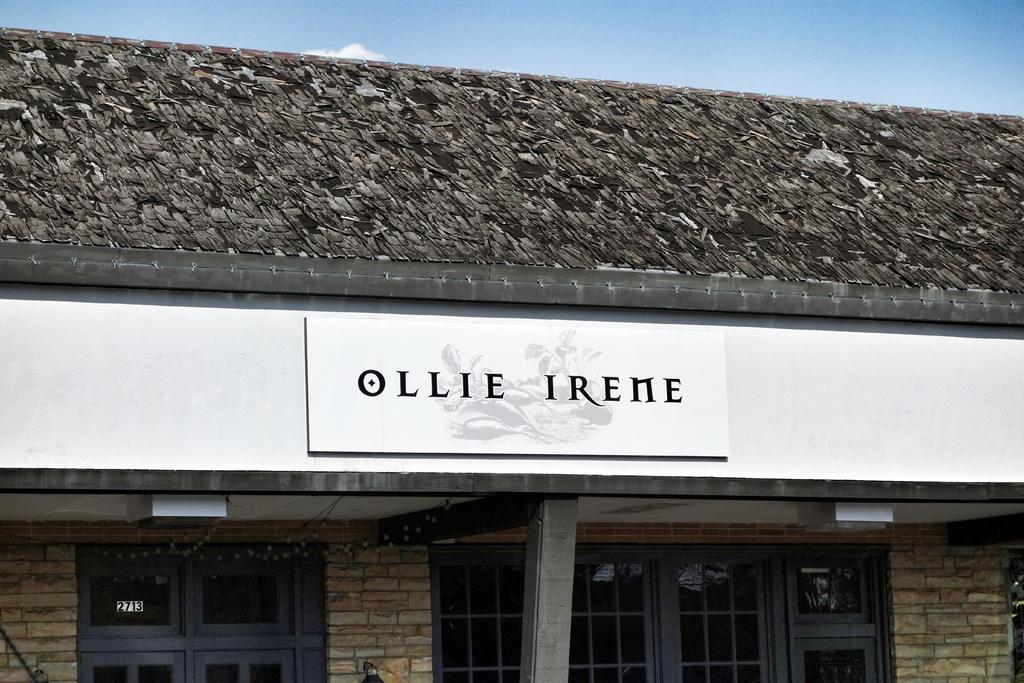What type of structure is visible in the image? There is a building in the image. What feature can be seen on the building? The building has windows. Is there any additional information displayed on the building? Yes, there is a banner on the building. What type of linen is used to cover the windows in the image? There is no mention of linen or any specific window covering in the image. 